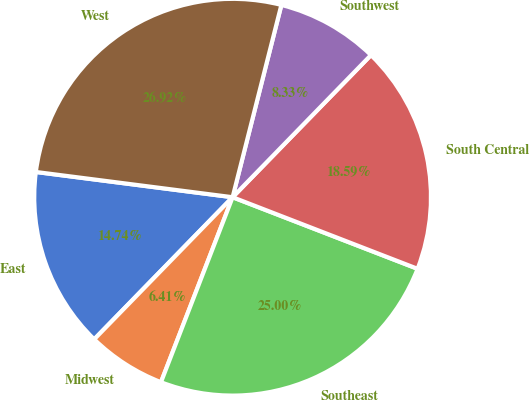Convert chart to OTSL. <chart><loc_0><loc_0><loc_500><loc_500><pie_chart><fcel>East<fcel>Midwest<fcel>Southeast<fcel>South Central<fcel>Southwest<fcel>West<nl><fcel>14.74%<fcel>6.41%<fcel>25.0%<fcel>18.59%<fcel>8.33%<fcel>26.92%<nl></chart> 